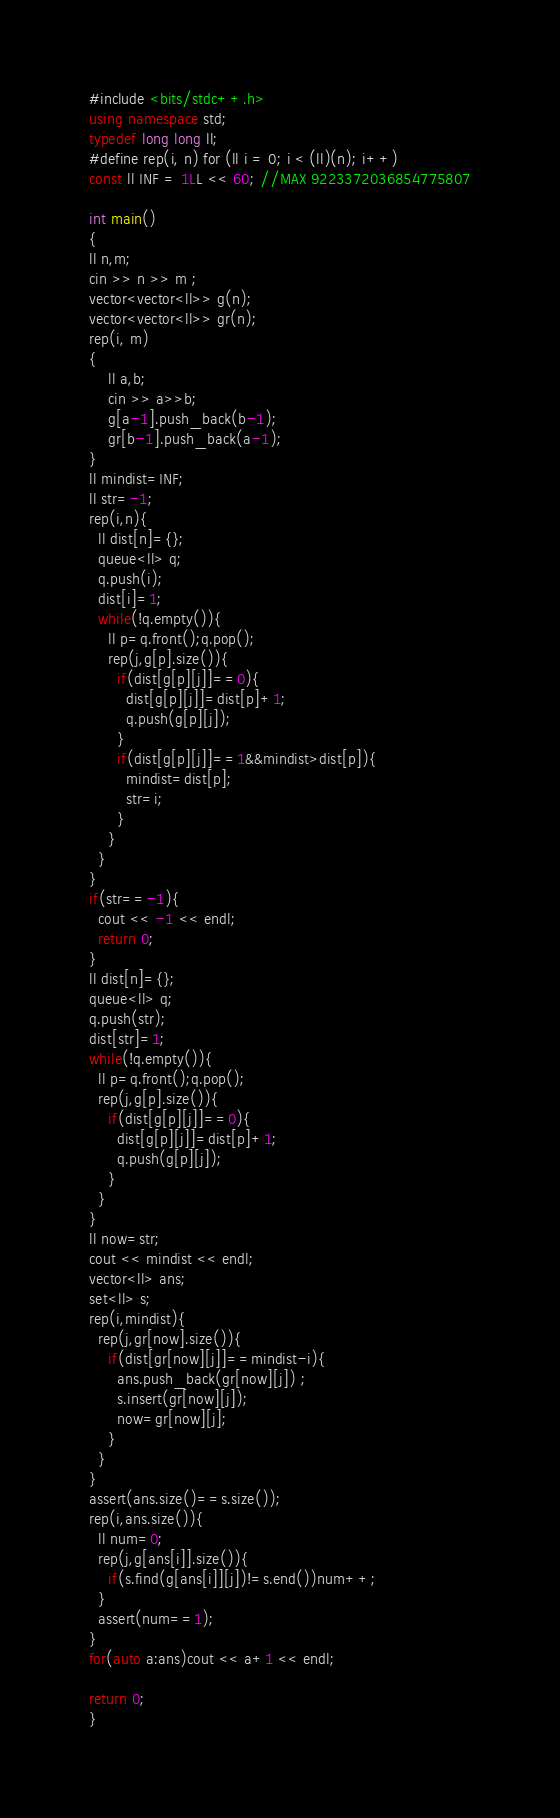Convert code to text. <code><loc_0><loc_0><loc_500><loc_500><_C++_>#include <bits/stdc++.h>
using namespace std;
typedef long long ll;
#define rep(i, n) for (ll i = 0; i < (ll)(n); i++)
const ll INF = 1LL << 60; //MAX 9223372036854775807

int main()
{
ll n,m;
cin >> n >> m ;
vector<vector<ll>> g(n);
vector<vector<ll>> gr(n);
rep(i, m)
{
    ll a,b;
    cin >> a>>b;
    g[a-1].push_back(b-1);
    gr[b-1].push_back(a-1);
}
ll mindist=INF;
ll str=-1;
rep(i,n){
  ll dist[n]={};
  queue<ll> q;
  q.push(i);
  dist[i]=1;
  while(!q.empty()){
    ll p=q.front();q.pop();
    rep(j,g[p].size()){
      if(dist[g[p][j]]==0){
        dist[g[p][j]]=dist[p]+1;
        q.push(g[p][j]);
      }
      if(dist[g[p][j]]==1&&mindist>dist[p]){
        mindist=dist[p];
        str=i;
      }
    }
  }
}
if(str==-1){
  cout << -1 << endl;
  return 0;
}
ll dist[n]={};
queue<ll> q;
q.push(str);
dist[str]=1;
while(!q.empty()){
  ll p=q.front();q.pop();
  rep(j,g[p].size()){
    if(dist[g[p][j]]==0){
      dist[g[p][j]]=dist[p]+1;
      q.push(g[p][j]);
    }
  }
}
ll now=str;
cout << mindist << endl;
vector<ll> ans;
set<ll> s;
rep(i,mindist){
  rep(j,gr[now].size()){
    if(dist[gr[now][j]]==mindist-i){
      ans.push_back(gr[now][j]) ;
      s.insert(gr[now][j]);
      now=gr[now][j];
    }
  }
}
assert(ans.size()==s.size());
rep(i,ans.size()){
  ll num=0;
  rep(j,g[ans[i]].size()){
    if(s.find(g[ans[i]][j])!=s.end())num++;
  }
  assert(num==1);
}
for(auto a:ans)cout << a+1 << endl;

return 0;
}</code> 